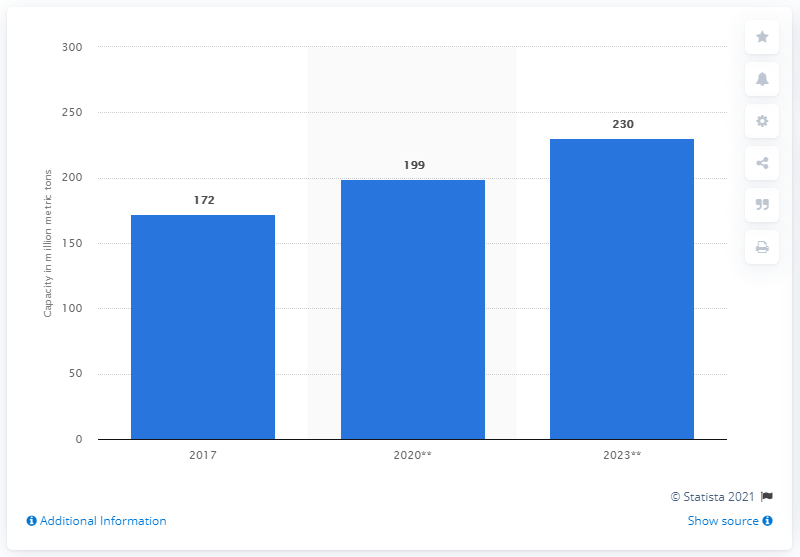Highlight a few significant elements in this photo. In 2017, the total production capacity for polyethylene and polypropylene was 172 million metric tons. 